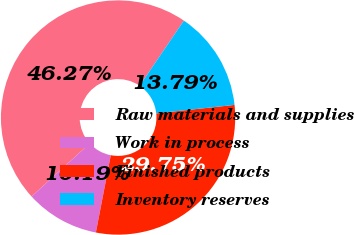<chart> <loc_0><loc_0><loc_500><loc_500><pie_chart><fcel>Raw materials and supplies<fcel>Work in process<fcel>Finished products<fcel>Inventory reserves<nl><fcel>46.27%<fcel>10.19%<fcel>29.75%<fcel>13.79%<nl></chart> 